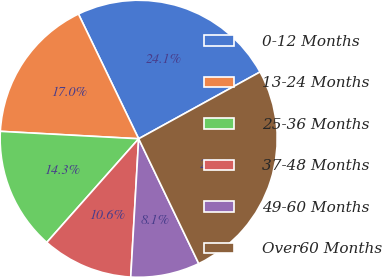Convert chart. <chart><loc_0><loc_0><loc_500><loc_500><pie_chart><fcel>0-12 Months<fcel>13-24 Months<fcel>25-36 Months<fcel>37-48 Months<fcel>49-60 Months<fcel>Over60 Months<nl><fcel>24.15%<fcel>16.99%<fcel>14.31%<fcel>10.63%<fcel>8.05%<fcel>25.87%<nl></chart> 